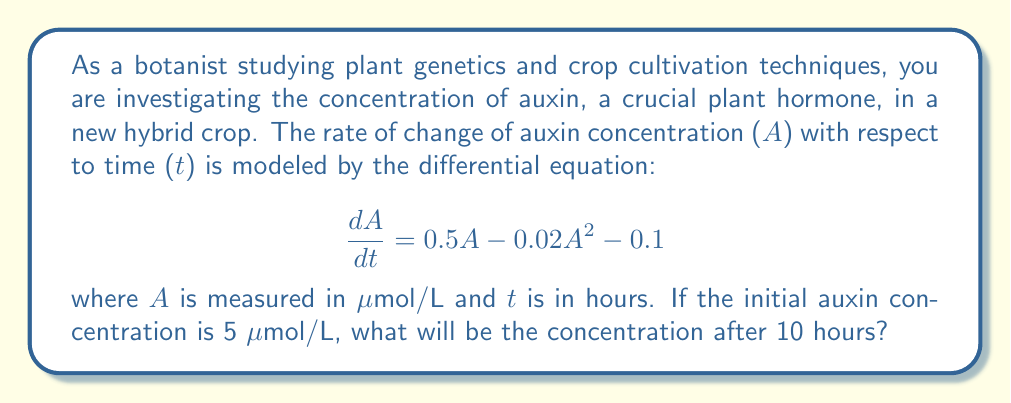Could you help me with this problem? To solve this problem, we need to use numerical methods to approximate the solution of the given differential equation. We'll use the fourth-order Runge-Kutta method (RK4) to obtain an accurate estimate.

The given differential equation is:

$$\frac{dA}{dt} = 0.5A - 0.02A^2 - 0.1$$

Let's define $f(A) = 0.5A - 0.02A^2 - 0.1$

The RK4 method for this equation is:

$$A_{n+1} = A_n + \frac{1}{6}(k_1 + 2k_2 + 2k_3 + k_4)$$

where:
$$k_1 = h \cdot f(A_n)$$
$$k_2 = h \cdot f(A_n + \frac{1}{2}k_1)$$
$$k_3 = h \cdot f(A_n + \frac{1}{2}k_2)$$
$$k_4 = h \cdot f(A_n + k_3)$$

We'll use a step size of h = 1 hour and perform 10 iterations.

Initial conditions: $A_0 = 5$ μmol/L, $t_0 = 0$ hours

Iteration 1:
$k_1 = 1 \cdot (0.5 \cdot 5 - 0.02 \cdot 5^2 - 0.1) = 0.9$
$k_2 = 1 \cdot (0.5 \cdot (5 + 0.5 \cdot 0.9) - 0.02 \cdot (5 + 0.5 \cdot 0.9)^2 - 0.1) = 0.8775$
$k_3 = 1 \cdot (0.5 \cdot (5 + 0.5 \cdot 0.8775) - 0.02 \cdot (5 + 0.5 \cdot 0.8775)^2 - 0.1) = 0.8663$
$k_4 = 1 \cdot (0.5 \cdot (5 + 0.8663) - 0.02 \cdot (5 + 0.8663)^2 - 0.1) = 0.8326$

$A_1 = 5 + \frac{1}{6}(0.9 + 2 \cdot 0.8775 + 2 \cdot 0.8663 + 0.8326) = 5.8700$ μmol/L

We continue this process for the remaining 9 iterations. The results are:

$A_2 = 6.6076$ μmol/L
$A_3 = 7.2260$ μmol/L
$A_4 = 7.7381$ μmol/L
$A_5 = 8.1559$ μmol/L
$A_6 = 8.4910$ μmol/L
$A_7 = 8.7538$ μmol/L
$A_8 = 8.9537$ μmol/L
$A_9 = 9.1000$ μmol/L
$A_{10} = 9.2009$ μmol/L

Therefore, after 10 hours, the auxin concentration will be approximately 9.2009 μmol/L.
Answer: 9.2009 μmol/L 